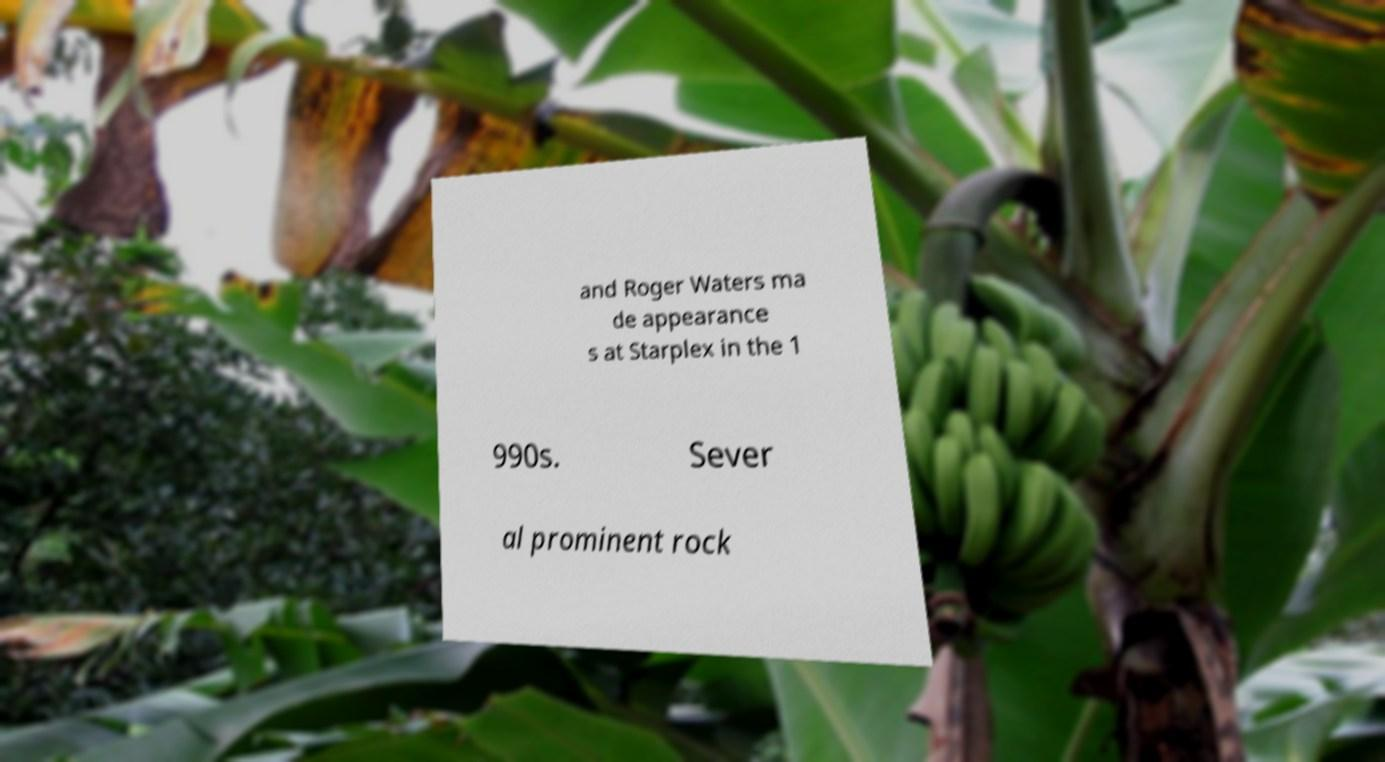Please identify and transcribe the text found in this image. and Roger Waters ma de appearance s at Starplex in the 1 990s. Sever al prominent rock 